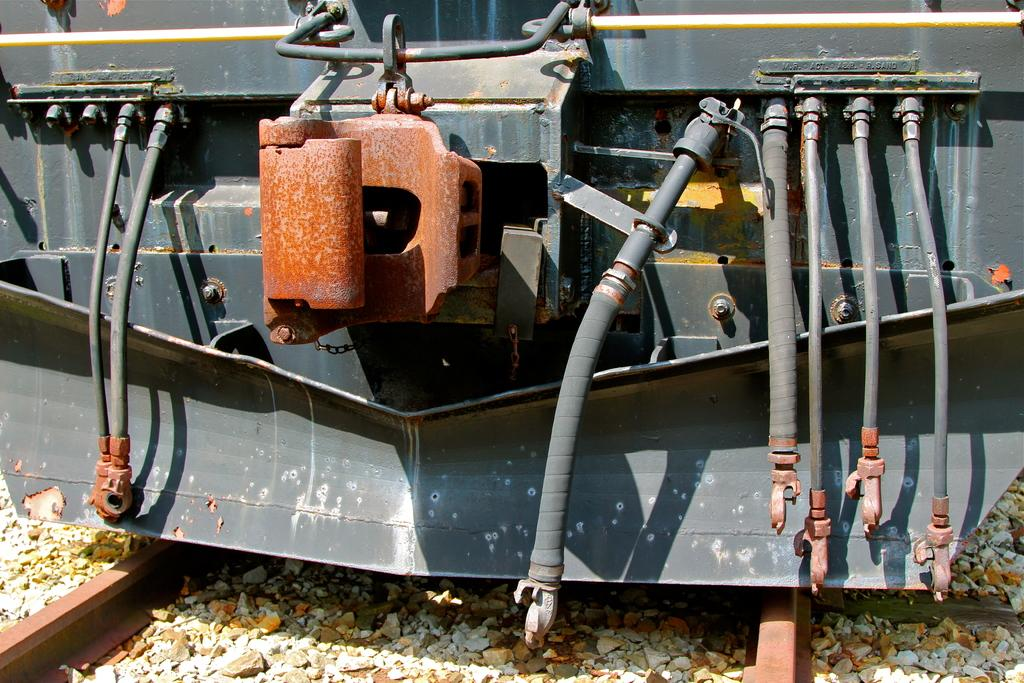What is the main subject of the image? The main subject of the image is a train. What is the train's position in the image? The train is on a track. Can you describe the track's surface? The track has small stones. What additional feature can be seen on the train? There are pipes attached to the front of the train. What type of chicken is being used as a print on the train's exterior? There is no chicken or print present on the train's exterior in the image. 